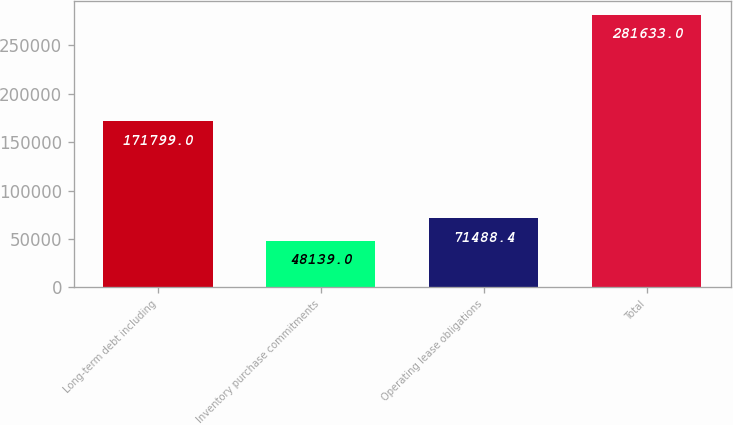Convert chart. <chart><loc_0><loc_0><loc_500><loc_500><bar_chart><fcel>Long-term debt including<fcel>Inventory purchase commitments<fcel>Operating lease obligations<fcel>Total<nl><fcel>171799<fcel>48139<fcel>71488.4<fcel>281633<nl></chart> 